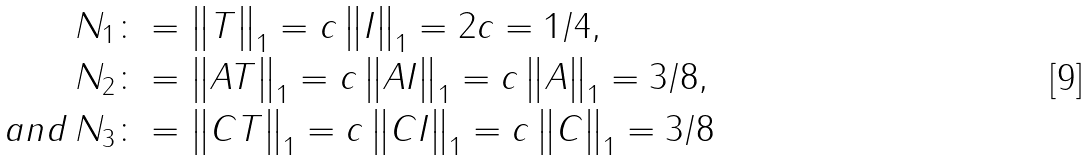Convert formula to latex. <formula><loc_0><loc_0><loc_500><loc_500>N _ { 1 } & \colon = \left \| T \right \| _ { 1 } = c \left \| I \right \| _ { 1 } = 2 c = 1 / 4 , \\ N _ { 2 } & \colon = \left \| A T \right \| _ { 1 } = c \left \| A I \right \| _ { 1 } = c \left \| A \right \| _ { 1 } = 3 / 8 , \\ a n d \, N _ { 3 } & \colon = \left \| C T \right \| _ { 1 } = c \left \| C I \right \| _ { 1 } = c \left \| C \right \| _ { 1 } = 3 / 8</formula> 